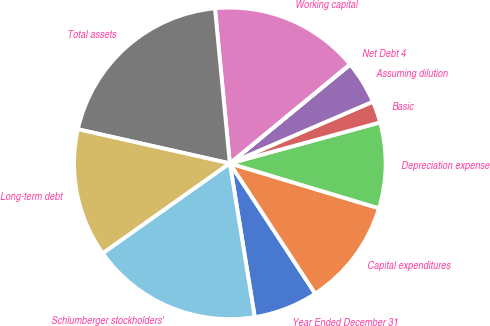Convert chart to OTSL. <chart><loc_0><loc_0><loc_500><loc_500><pie_chart><fcel>Year Ended December 31<fcel>Capital expenditures<fcel>Depreciation expense<fcel>Basic<fcel>Assuming dilution<fcel>Net Debt 4<fcel>Working capital<fcel>Total assets<fcel>Long-term debt<fcel>Schlumberger stockholders'<nl><fcel>6.68%<fcel>11.11%<fcel>8.89%<fcel>2.25%<fcel>4.46%<fcel>0.04%<fcel>15.54%<fcel>19.96%<fcel>13.32%<fcel>17.75%<nl></chart> 